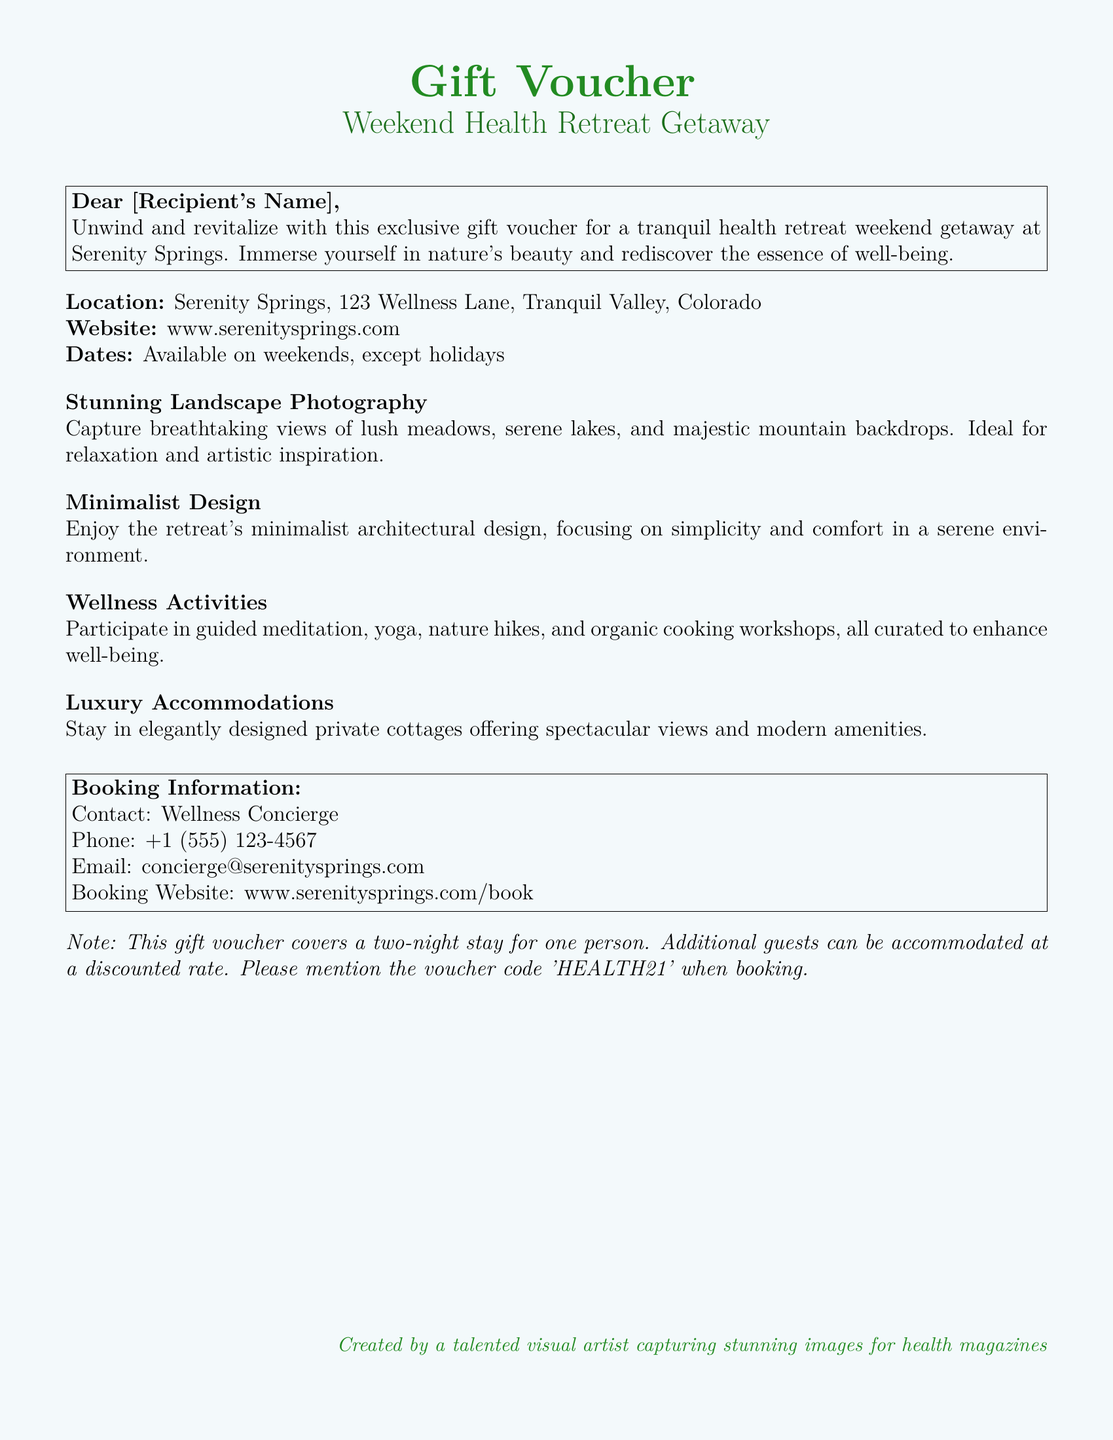What is the location of the retreat? The location of the retreat is mentioned in the document as “Serenity Springs, 123 Wellness Lane, Tranquil Valley, Colorado.”
Answer: Serenity Springs, 123 Wellness Lane, Tranquil Valley, Colorado What is included in the gift voucher? The document states that the gift voucher covers a two-night stay for one person, with mention of additional guests at a discounted rate.
Answer: Two-night stay for one person What is the voucher code for booking? The document specifically mentions a voucher code that must be mentioned when booking, which is 'HEALTH21.'
Answer: HEALTH21 What activities are offered at the retreat? The document lists activities such as guided meditation, yoga, nature hikes, and organic cooking workshops.
Answer: Guided meditation, yoga, nature hikes, organic cooking workshops Who should be contacted for booking information? The document provides contact details for the "Wellness Concierge" for booking inquiries.
Answer: Wellness Concierge What type of design does the retreat emphasize? The document highlights the design as "minimalist," focusing on simplicity and comfort.
Answer: Minimalist When are the available dates for the retreat? According to the document, the retreat is available on weekends, except for holidays.
Answer: Weekends, except holidays What type of accommodations are offered? The document refers to the accommodations as "elegantly designed private cottages."
Answer: Elegantly designed private cottages What is the phone number for the concierge? The document provides a specific phone number for the concierge, which is +1 (555) 123-4567.
Answer: +1 (555) 123-4567 